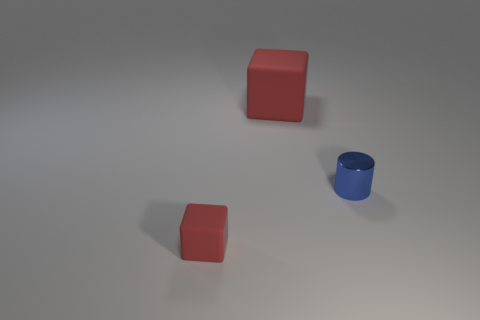How big is the object that is behind the tiny red object and on the left side of the cylinder?
Provide a short and direct response. Large. What is the material of the thing that is the same size as the metal cylinder?
Ensure brevity in your answer.  Rubber. There is another object that is the same material as the large red thing; what size is it?
Your answer should be very brief. Small. There is a thing that is both in front of the large red rubber block and to the left of the blue metallic thing; what is its color?
Offer a very short reply. Red. There is a tiny thing right of the red thing that is in front of the red block that is on the right side of the tiny matte cube; what is it made of?
Your answer should be very brief. Metal. Are there any other things that are the same material as the small red cube?
Provide a short and direct response. Yes. Is the color of the rubber cube that is left of the big red matte thing the same as the shiny cylinder?
Offer a very short reply. No. How many blue things are either tiny shiny objects or tiny rubber blocks?
Keep it short and to the point. 1. What number of other objects are the same shape as the large object?
Ensure brevity in your answer.  1. Do the large red block and the small red block have the same material?
Provide a short and direct response. Yes. 